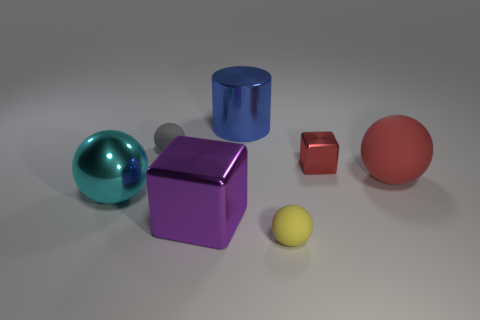Add 2 big yellow cylinders. How many objects exist? 9 Subtract all cyan cylinders. Subtract all blue cubes. How many cylinders are left? 1 Subtract all balls. How many objects are left? 3 Subtract 0 gray cylinders. How many objects are left? 7 Subtract all blue shiny cylinders. Subtract all red balls. How many objects are left? 5 Add 1 big metal spheres. How many big metal spheres are left? 2 Add 4 cyan shiny spheres. How many cyan shiny spheres exist? 5 